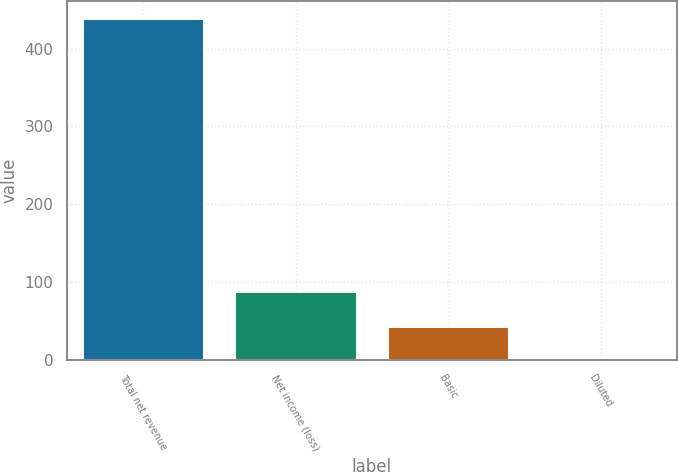Convert chart to OTSL. <chart><loc_0><loc_0><loc_500><loc_500><bar_chart><fcel>Total net revenue<fcel>Net income (loss)<fcel>Basic<fcel>Diluted<nl><fcel>439<fcel>89<fcel>44.17<fcel>0.3<nl></chart> 